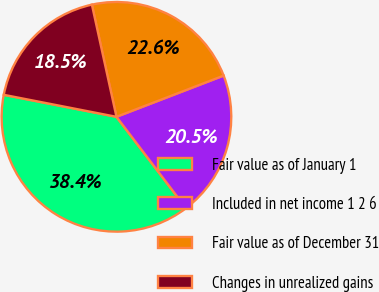Convert chart. <chart><loc_0><loc_0><loc_500><loc_500><pie_chart><fcel>Fair value as of January 1<fcel>Included in net income 1 2 6<fcel>Fair value as of December 31<fcel>Changes in unrealized gains<nl><fcel>38.43%<fcel>20.49%<fcel>22.59%<fcel>18.5%<nl></chart> 